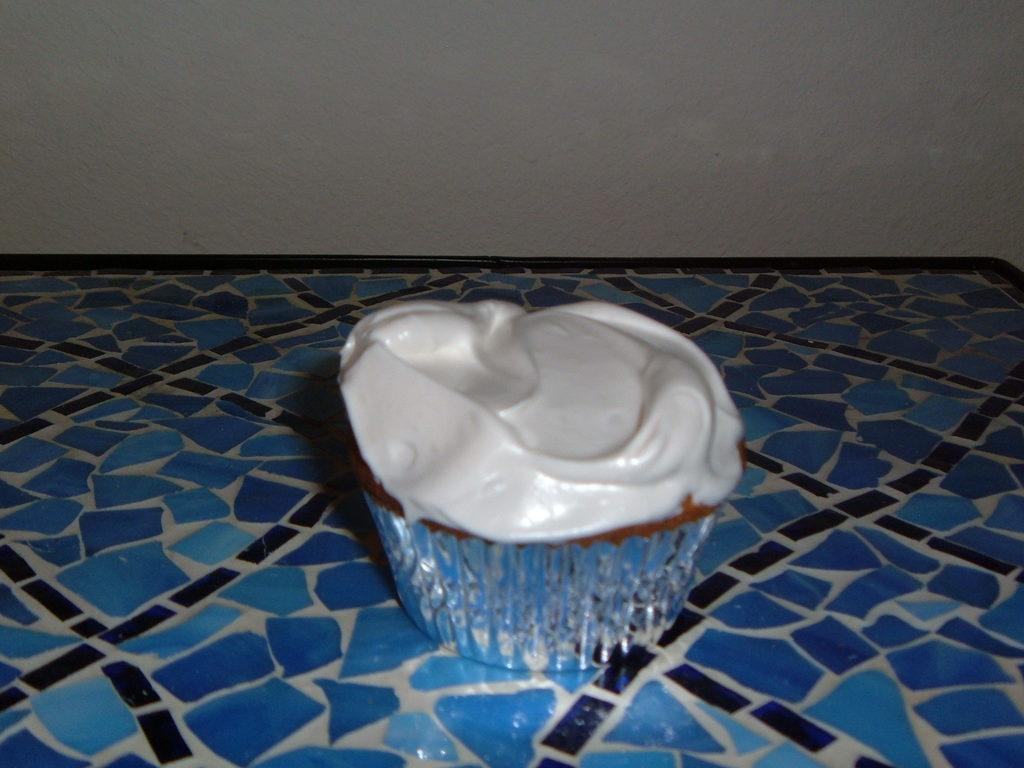What type of object is present in the image? There is an edible in the image. Can you describe the surface on which the edible is placed? The edible is placed on a blue surface. What type of seat is visible in the image? There is no seat present in the image; it only features an edible placed on a blue surface. 